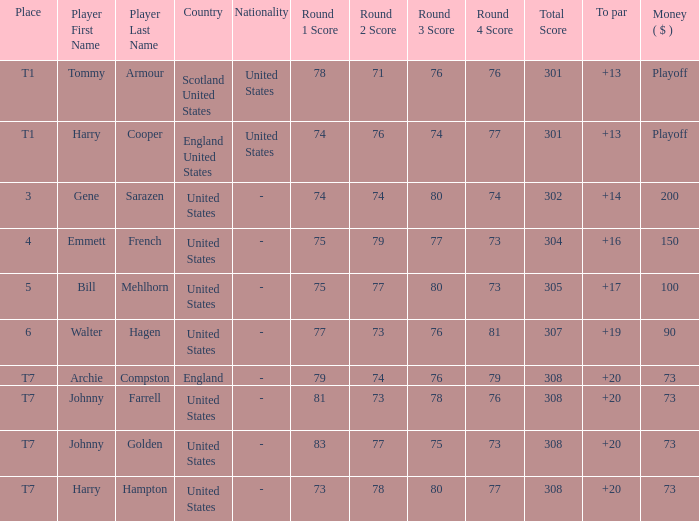What is the placement when archie compston is the contender and the currency is $73? T7. 